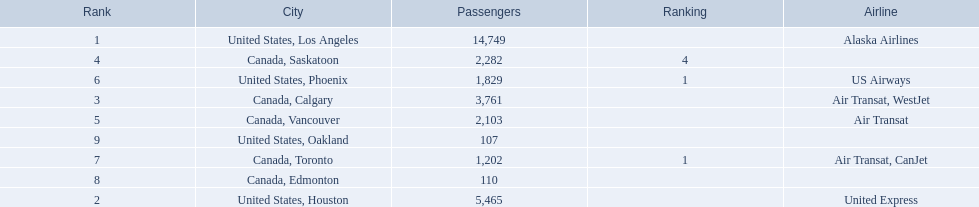Which cities had less than 2,000 passengers? United States, Phoenix, Canada, Toronto, Canada, Edmonton, United States, Oakland. Of these cities, which had fewer than 1,000 passengers? Canada, Edmonton, United States, Oakland. Of the cities in the previous answer, which one had only 107 passengers? United States, Oakland. 